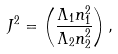<formula> <loc_0><loc_0><loc_500><loc_500>J ^ { 2 } = \left ( \frac { \Lambda _ { 1 } n _ { 1 } ^ { 2 } } { \Lambda _ { 2 } n _ { 2 } ^ { 2 } } \right ) ,</formula> 